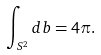<formula> <loc_0><loc_0><loc_500><loc_500>\int _ { S ^ { 2 } } d b = 4 \pi .</formula> 